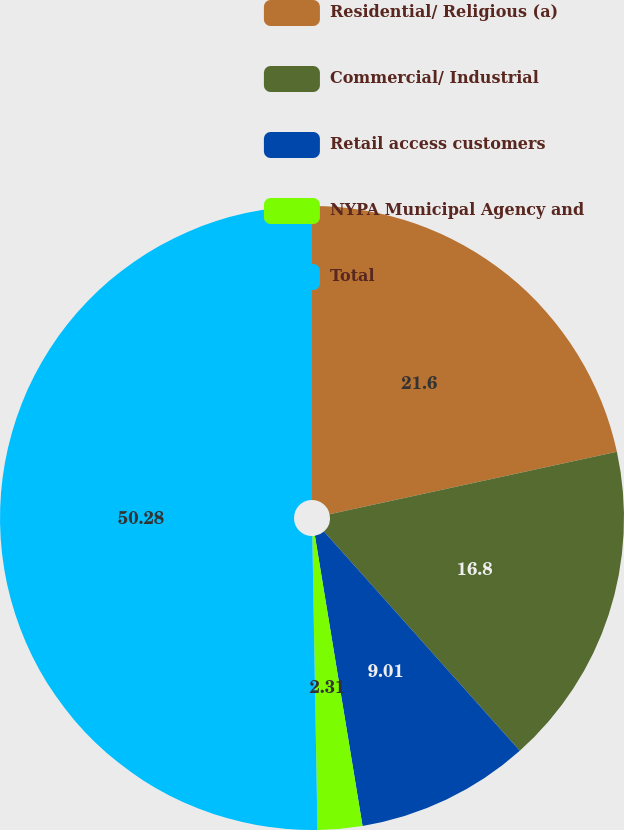<chart> <loc_0><loc_0><loc_500><loc_500><pie_chart><fcel>Residential/ Religious (a)<fcel>Commercial/ Industrial<fcel>Retail access customers<fcel>NYPA Municipal Agency and<fcel>Total<nl><fcel>21.6%<fcel>16.8%<fcel>9.01%<fcel>2.31%<fcel>50.28%<nl></chart> 